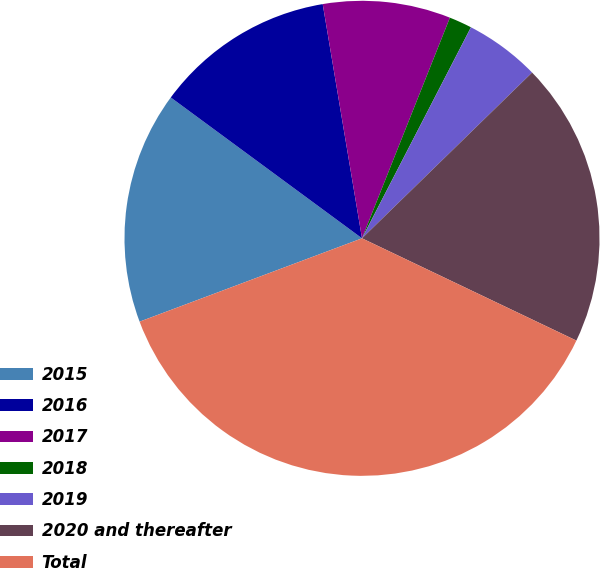Convert chart to OTSL. <chart><loc_0><loc_0><loc_500><loc_500><pie_chart><fcel>2015<fcel>2016<fcel>2017<fcel>2018<fcel>2019<fcel>2020 and thereafter<fcel>Total<nl><fcel>15.81%<fcel>12.25%<fcel>8.68%<fcel>1.55%<fcel>5.12%<fcel>19.38%<fcel>37.21%<nl></chart> 